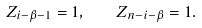Convert formula to latex. <formula><loc_0><loc_0><loc_500><loc_500>Z _ { i - \beta - 1 } = 1 , \quad Z _ { n - i - \beta } = 1 .</formula> 